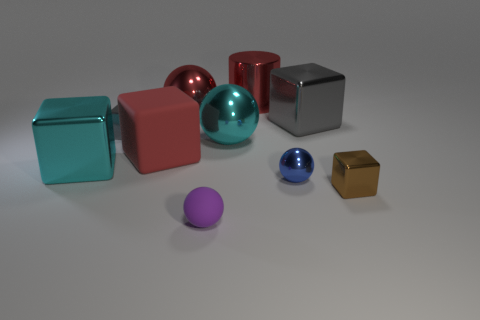Subtract all cyan spheres. How many spheres are left? 3 Subtract all gray spheres. How many gray blocks are left? 2 Subtract 3 blocks. How many blocks are left? 2 Subtract all red cubes. How many cubes are left? 4 Subtract all balls. How many objects are left? 6 Add 3 big cyan cubes. How many big cyan cubes are left? 4 Add 8 metallic cylinders. How many metallic cylinders exist? 9 Subtract 0 brown cylinders. How many objects are left? 10 Subtract all blue spheres. Subtract all red cylinders. How many spheres are left? 3 Subtract all big green metal cylinders. Subtract all big cyan shiny objects. How many objects are left? 8 